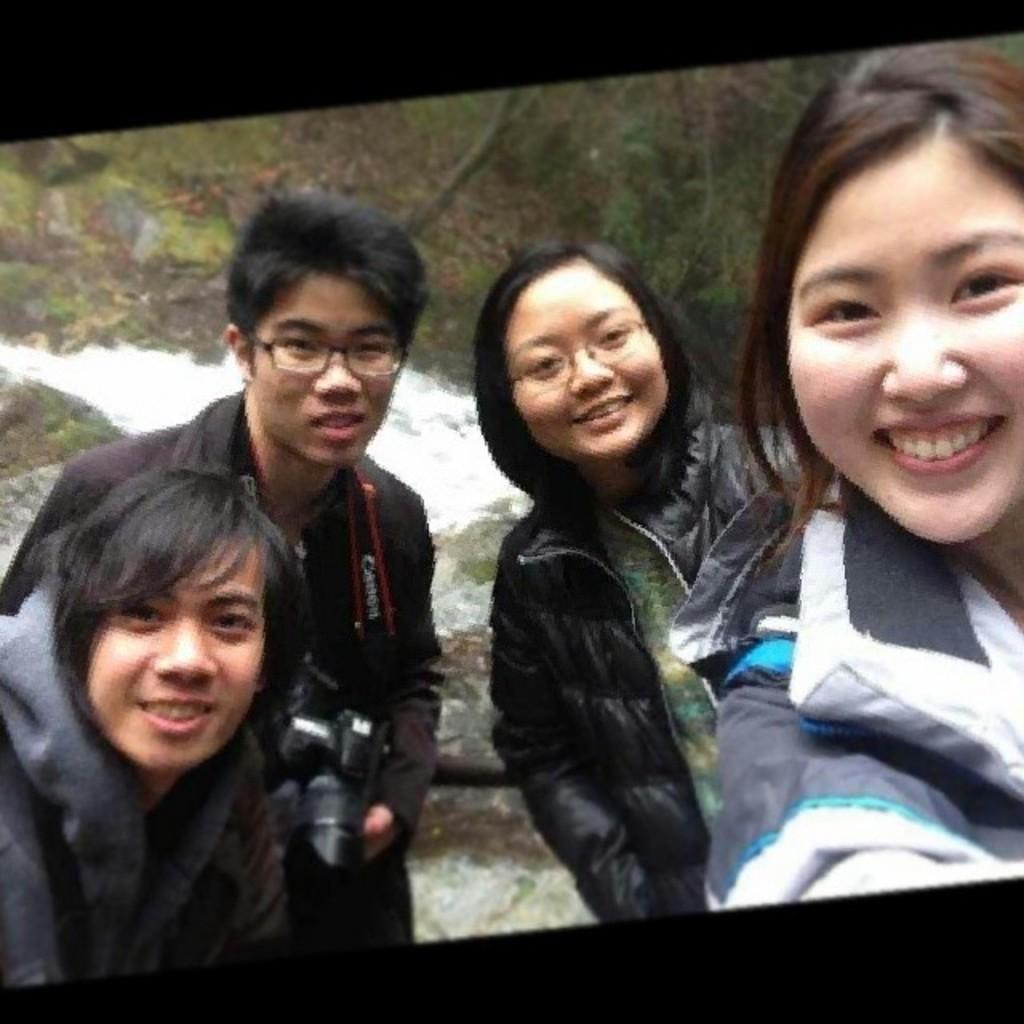What is the man doing on the left side of the image? The man is standing on the left side of the image and holding a camera. Who else is present in the image? There are two girls standing on the right side of the image. What is the expression on the girls' faces? The girls are smiling. What can be seen in the background of the image? There are trees visible at the top of the image. What type of payment is being made by the governor in the image? There is no governor present in the image, and therefore no payment can be observed. What is the height of the low tree visible in the image? There is no mention of a tree being low in the image, and only trees visible at the top of the image are mentioned. 